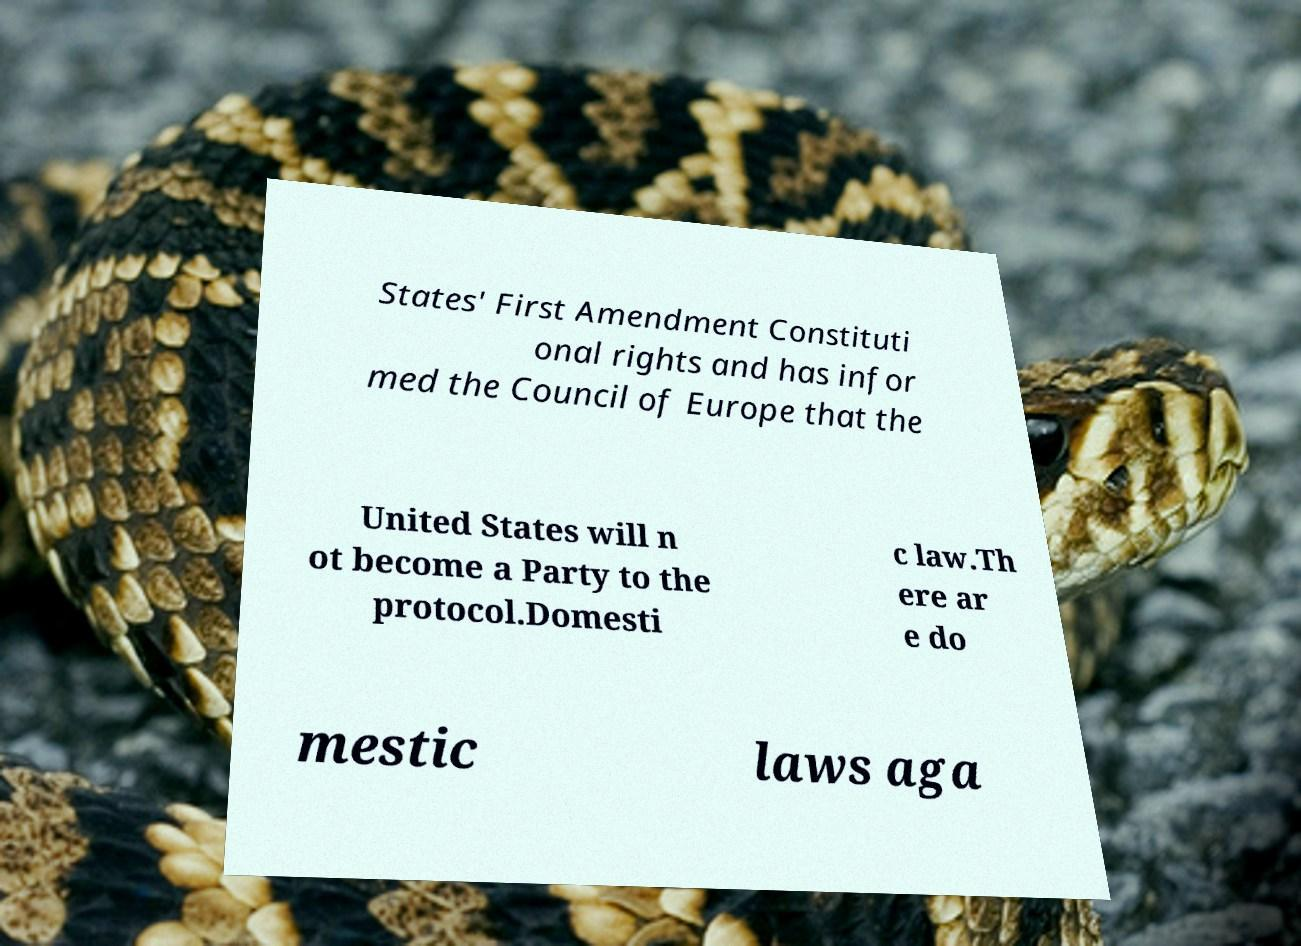Can you accurately transcribe the text from the provided image for me? States' First Amendment Constituti onal rights and has infor med the Council of Europe that the United States will n ot become a Party to the protocol.Domesti c law.Th ere ar e do mestic laws aga 